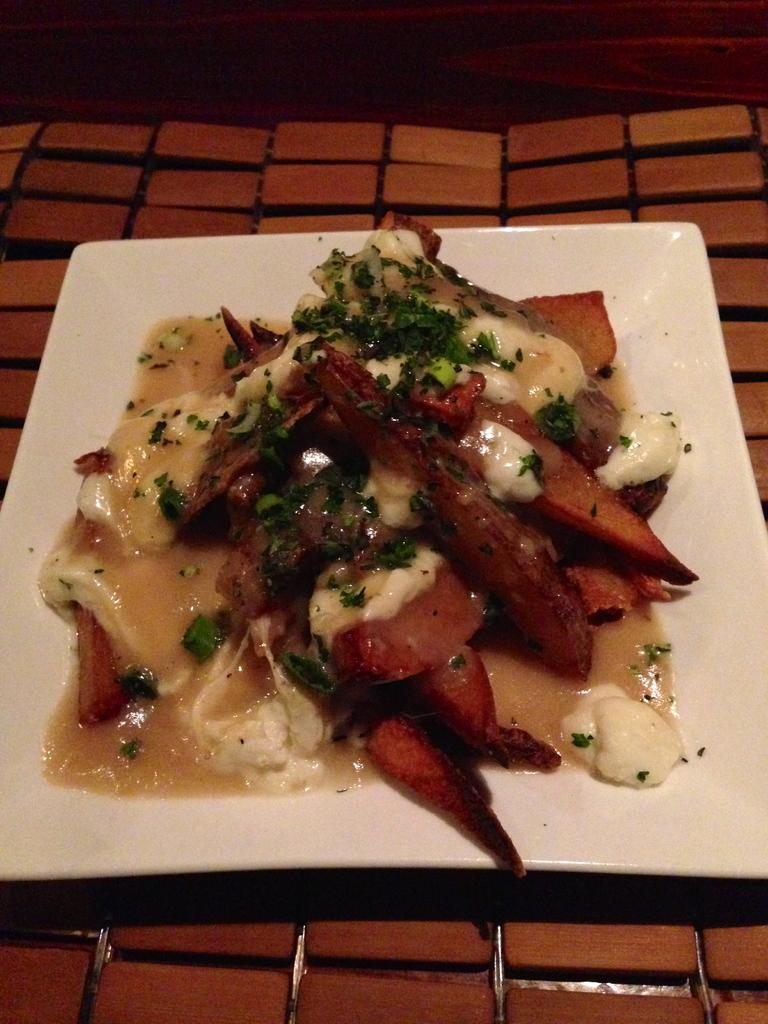What is the color of the plate or tray in the image? The plate or tray in the image is white. What is on the plate or tray? The plate or tray contains food items. On what surface is the plate or tray placed? The plate or tray is placed on a brown table. Can you see any kittens playing in the alley behind the brown table in the image? There is no alley or kittens present in the image; it only shows a white plate or tray containing food items placed on a brown table. 